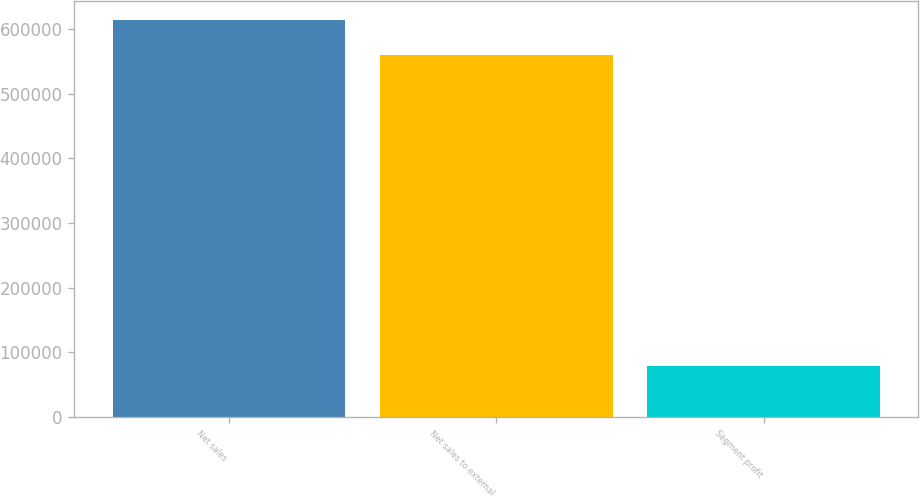Convert chart. <chart><loc_0><loc_0><loc_500><loc_500><bar_chart><fcel>Net sales<fcel>Net sales to external<fcel>Segment profit<nl><fcel>613353<fcel>560238<fcel>79448<nl></chart> 